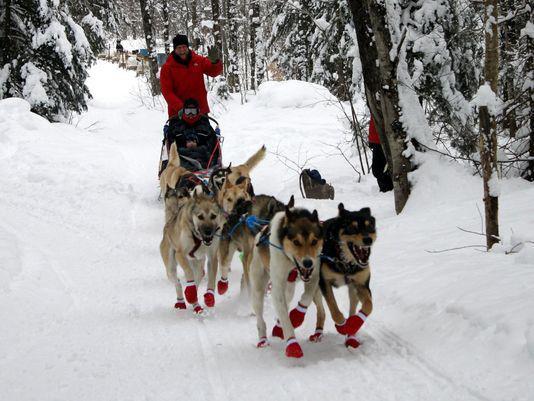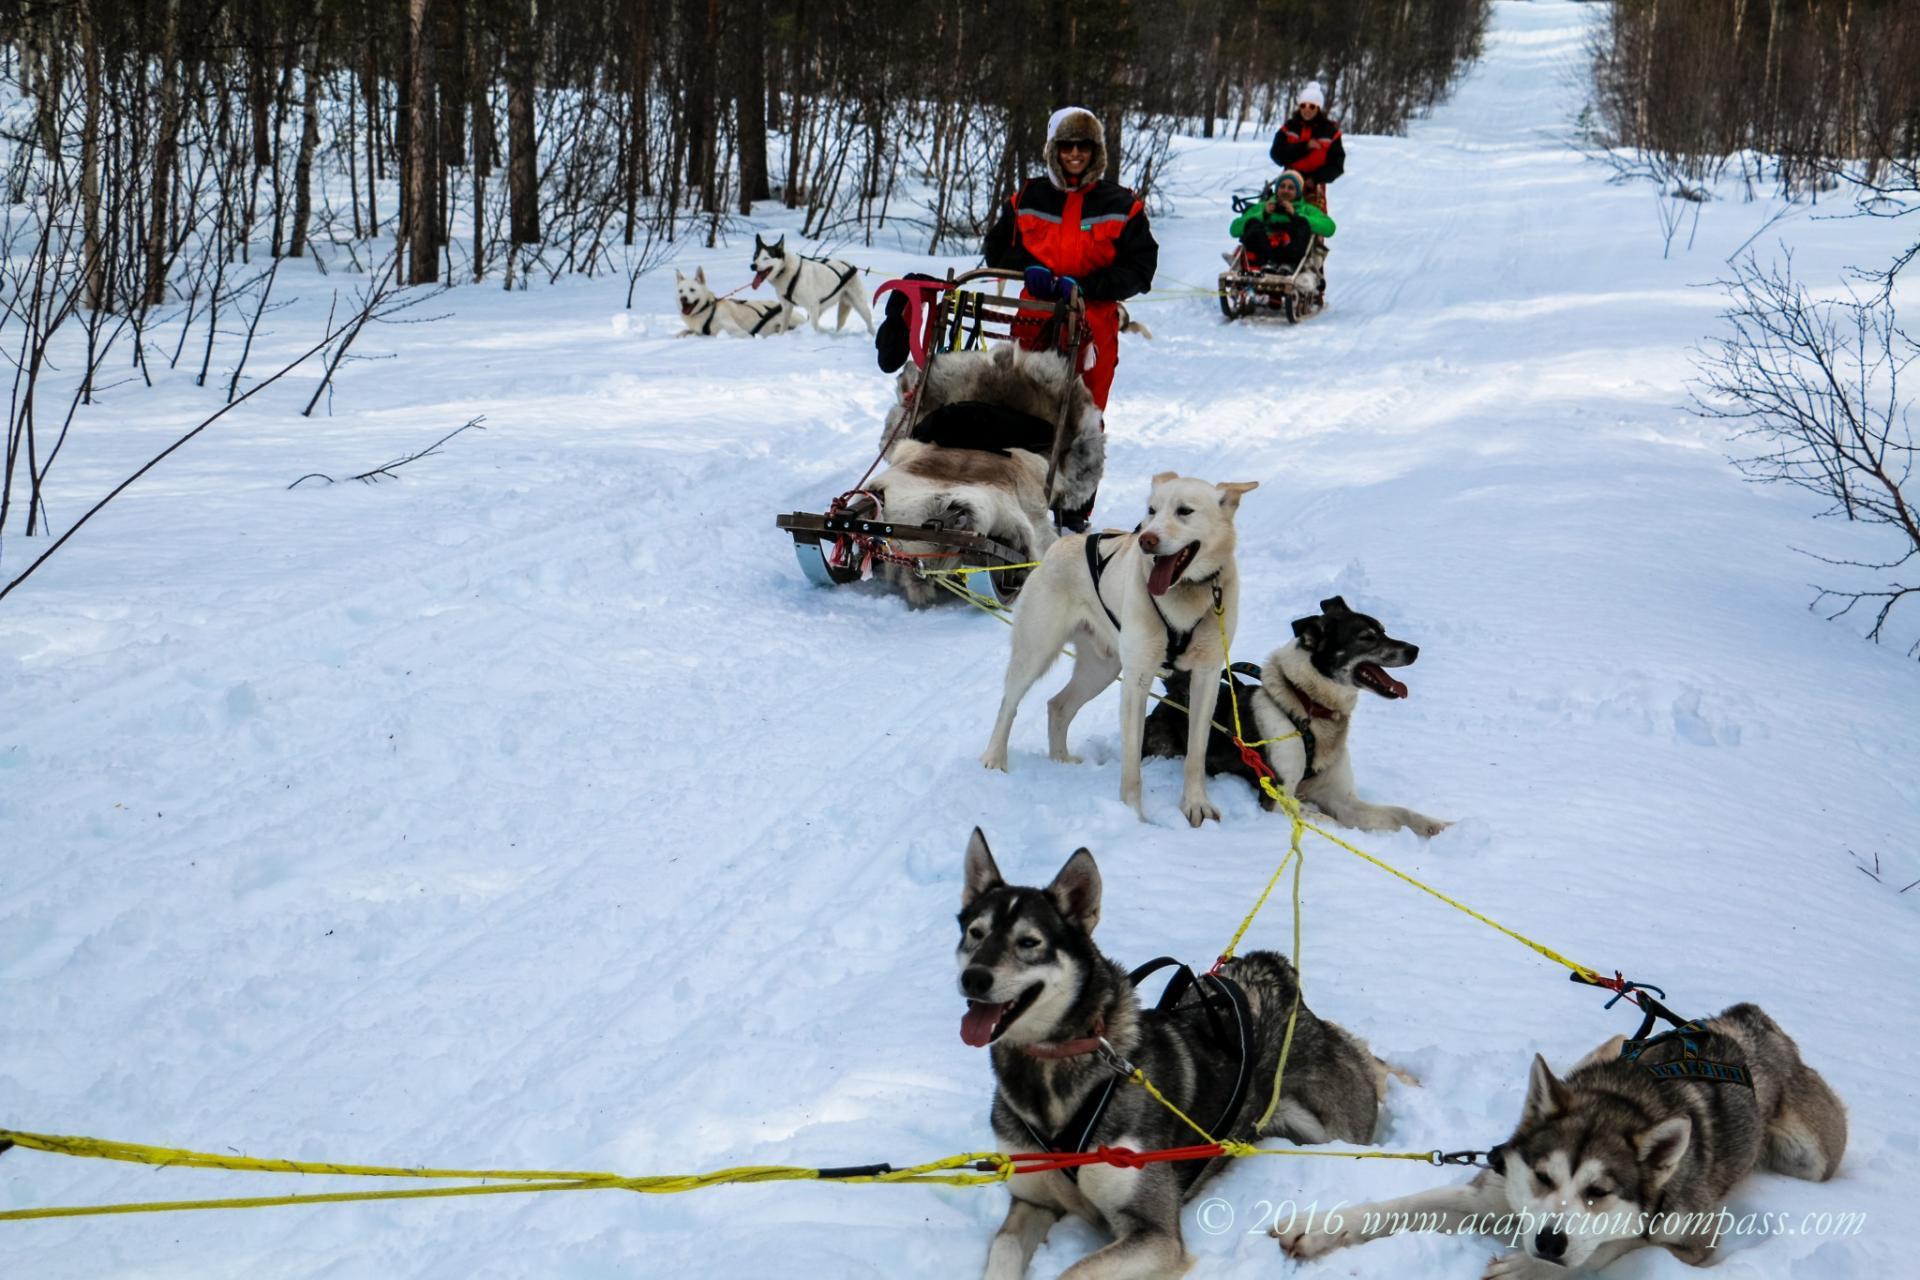The first image is the image on the left, the second image is the image on the right. Examine the images to the left and right. Is the description "At least one of the images shows a predominately black dog with white accents wearing a bright red harness on its body." accurate? Answer yes or no. No. 